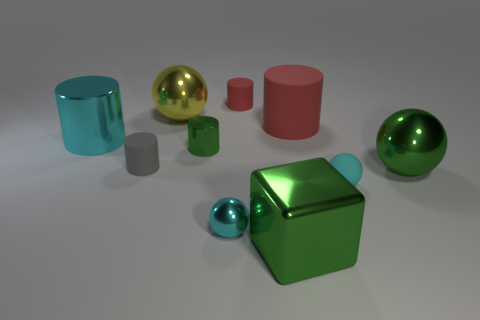How do the colors of the objects contribute to the overall composition? The colors in the image—ranging from transparent cyan to solid reds and greens—create a visually appealing palette that balances well. The variations in color add depth and interest, with cooler colors contrasting against warmer tones and neutrals. 